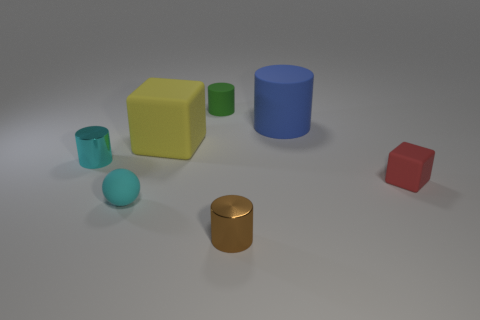Imagine if these objects were available as toys, what age group would they be suitable for? These objects, with their simple geometric shapes and vibrant colors, would be suitable as toys for young children, likely in the age range of 3 to 6 years old. They could help in learning about different shapes and colors. 